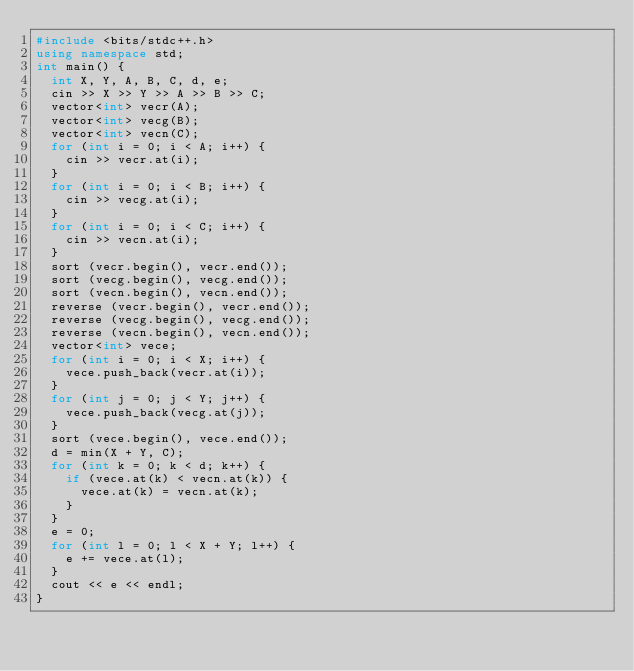<code> <loc_0><loc_0><loc_500><loc_500><_C++_>#include <bits/stdc++.h>
using namespace std;
int main() {
  int X, Y, A, B, C, d, e;
  cin >> X >> Y >> A >> B >> C;
  vector<int> vecr(A);
  vector<int> vecg(B);
  vector<int> vecn(C);
  for (int i = 0; i < A; i++) {
    cin >> vecr.at(i);
  }
  for (int i = 0; i < B; i++) {
    cin >> vecg.at(i);
  }
  for (int i = 0; i < C; i++) {
    cin >> vecn.at(i);
  }
  sort (vecr.begin(), vecr.end());
  sort (vecg.begin(), vecg.end());
  sort (vecn.begin(), vecn.end());
  reverse (vecr.begin(), vecr.end());
  reverse (vecg.begin(), vecg.end());
  reverse (vecn.begin(), vecn.end());
  vector<int> vece;
  for (int i = 0; i < X; i++) {
    vece.push_back(vecr.at(i));
  }
  for (int j = 0; j < Y; j++) {
    vece.push_back(vecg.at(j));
  }
  sort (vece.begin(), vece.end());
  d = min(X + Y, C);
  for (int k = 0; k < d; k++) {
    if (vece.at(k) < vecn.at(k)) {
      vece.at(k) = vecn.at(k);
    }
  }
  e = 0;
  for (int l = 0; l < X + Y; l++) {
    e += vece.at(l);
  }
  cout << e << endl;
}</code> 